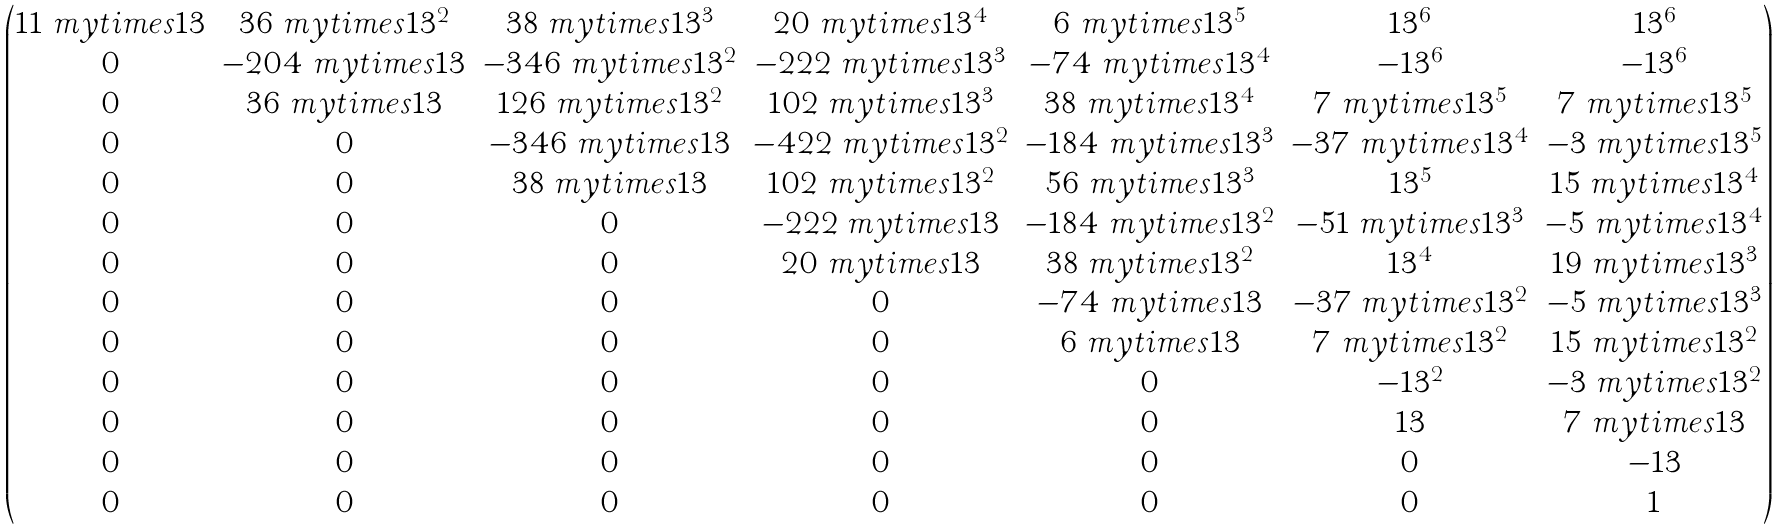<formula> <loc_0><loc_0><loc_500><loc_500>\begin{pmatrix} 1 1 \ m y t i m e s 1 3 & 3 6 \ m y t i m e s 1 3 ^ { 2 } & 3 8 \ m y t i m e s 1 3 ^ { 3 } & 2 0 \ m y t i m e s 1 3 ^ { 4 } & 6 \ m y t i m e s 1 3 ^ { 5 } & 1 3 ^ { 6 } & 1 3 ^ { 6 } \\ 0 & - 2 0 4 \ m y t i m e s 1 3 & - 3 4 6 \ m y t i m e s 1 3 ^ { 2 } & - 2 2 2 \ m y t i m e s 1 3 ^ { 3 } & - 7 4 \ m y t i m e s 1 3 ^ { 4 } & - 1 3 ^ { 6 } & - 1 3 ^ { 6 } \\ 0 & 3 6 \ m y t i m e s 1 3 & 1 2 6 \ m y t i m e s 1 3 ^ { 2 } & 1 0 2 \ m y t i m e s 1 3 ^ { 3 } & 3 8 \ m y t i m e s 1 3 ^ { 4 } & 7 \ m y t i m e s 1 3 ^ { 5 } & 7 \ m y t i m e s 1 3 ^ { 5 } \\ 0 & 0 & - 3 4 6 \ m y t i m e s 1 3 & - 4 2 2 \ m y t i m e s 1 3 ^ { 2 } & - 1 8 4 \ m y t i m e s 1 3 ^ { 3 } & - 3 7 \ m y t i m e s 1 3 ^ { 4 } & - 3 \ m y t i m e s 1 3 ^ { 5 } \\ 0 & 0 & 3 8 \ m y t i m e s 1 3 & 1 0 2 \ m y t i m e s 1 3 ^ { 2 } & 5 6 \ m y t i m e s 1 3 ^ { 3 } & 1 3 ^ { 5 } & 1 5 \ m y t i m e s 1 3 ^ { 4 } \\ 0 & 0 & 0 & - 2 2 2 \ m y t i m e s 1 3 & - 1 8 4 \ m y t i m e s 1 3 ^ { 2 } & - 5 1 \ m y t i m e s 1 3 ^ { 3 } & - 5 \ m y t i m e s 1 3 ^ { 4 } \\ 0 & 0 & 0 & 2 0 \ m y t i m e s 1 3 & 3 8 \ m y t i m e s 1 3 ^ { 2 } & 1 3 ^ { 4 } & 1 9 \ m y t i m e s 1 3 ^ { 3 } \\ 0 & 0 & 0 & 0 & - 7 4 \ m y t i m e s 1 3 & - 3 7 \ m y t i m e s 1 3 ^ { 2 } & - 5 \ m y t i m e s 1 3 ^ { 3 } \\ 0 & 0 & 0 & 0 & 6 \ m y t i m e s 1 3 & 7 \ m y t i m e s 1 3 ^ { 2 } & 1 5 \ m y t i m e s 1 3 ^ { 2 } \\ 0 & 0 & 0 & 0 & 0 & - 1 3 ^ { 2 } & - 3 \ m y t i m e s 1 3 ^ { 2 } \\ 0 & 0 & 0 & 0 & 0 & 1 3 & 7 \ m y t i m e s 1 3 \\ 0 & 0 & 0 & 0 & 0 & 0 & - 1 3 \\ 0 & 0 & 0 & 0 & 0 & 0 & 1 \end{pmatrix}</formula> 